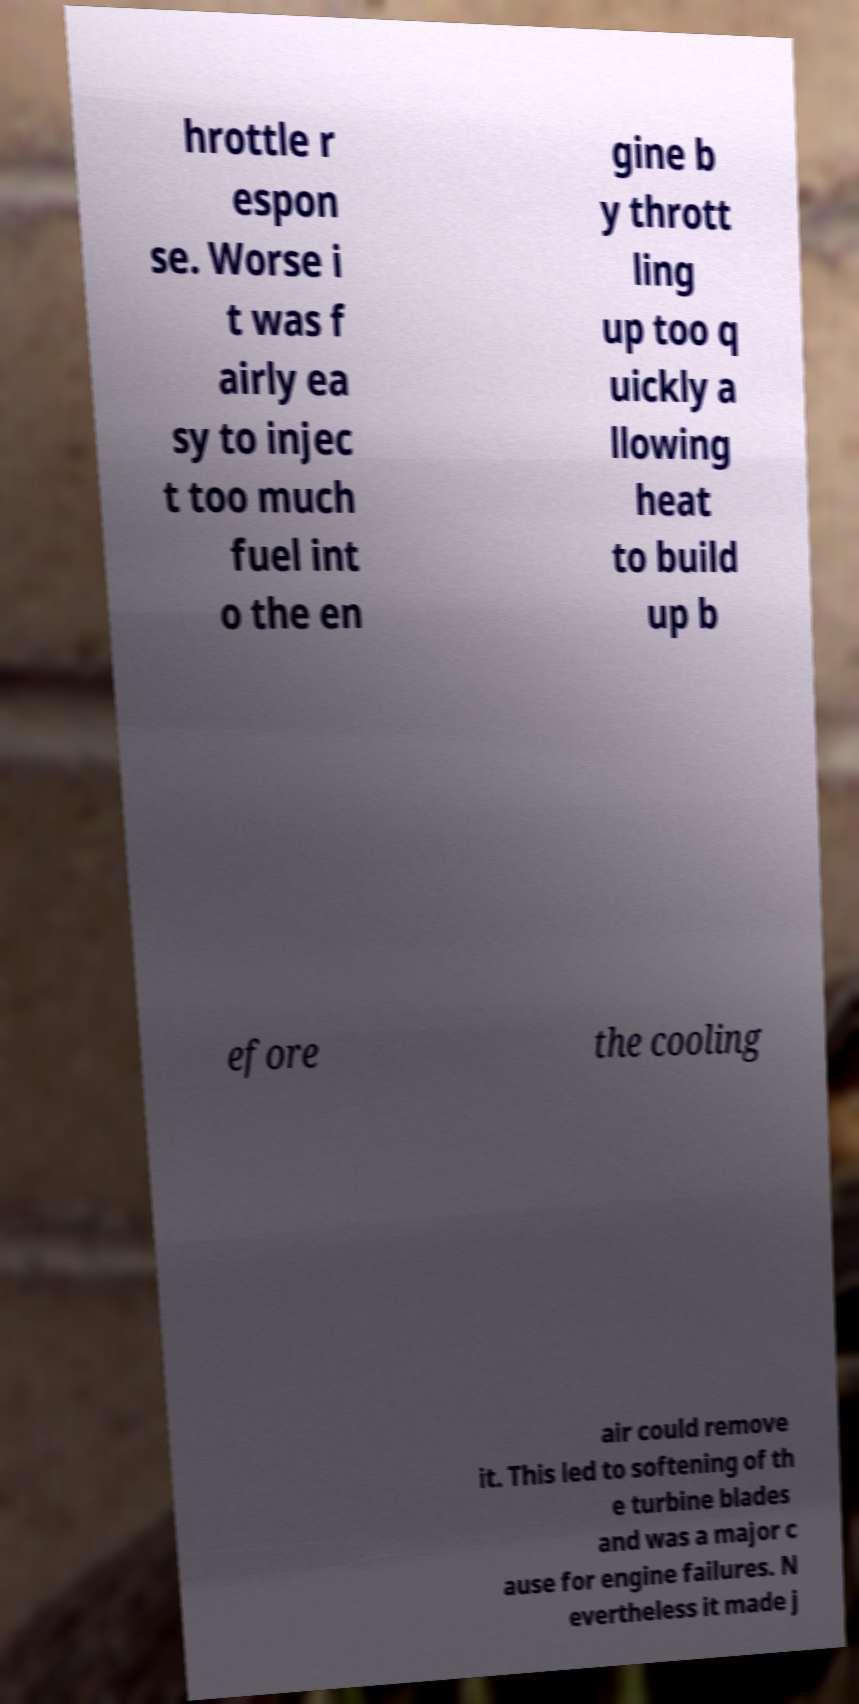Please read and relay the text visible in this image. What does it say? hrottle r espon se. Worse i t was f airly ea sy to injec t too much fuel int o the en gine b y thrott ling up too q uickly a llowing heat to build up b efore the cooling air could remove it. This led to softening of th e turbine blades and was a major c ause for engine failures. N evertheless it made j 